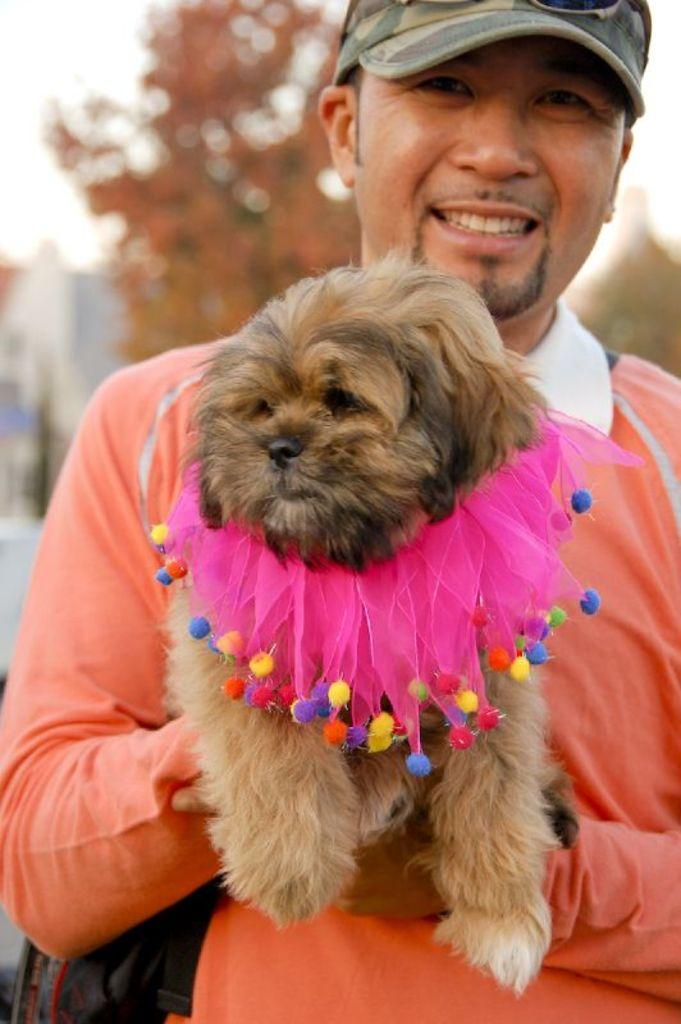Who is the main subject in the image? There is a man in the center of the image. What is the man doing in the image? The man is holding a dog. What is the man's facial expression in the image? The man is smiling. What can be seen in the background of the image? There is a tree in the background of the image. What is the tendency of the oranges in the image? There are no oranges present in the image. How does the sleet affect the man and the dog in the image? There is no sleet present in the image; it is a clear day with a man holding a dog. 